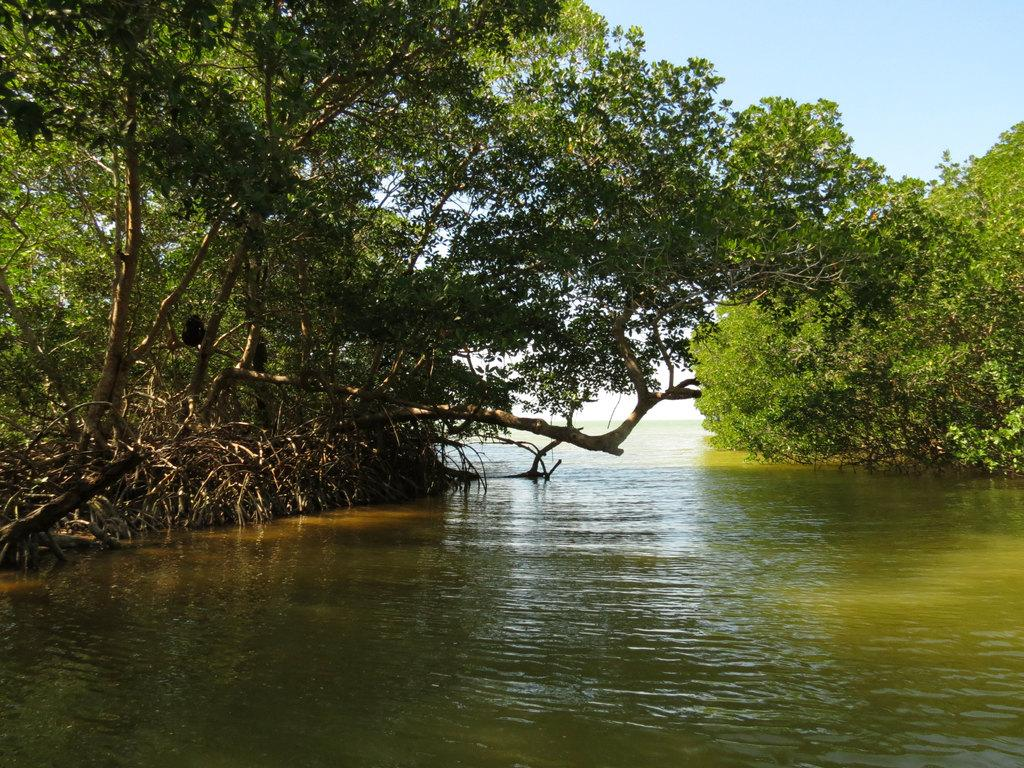What is the primary element visible in the image? There is water in the image. What type of vegetation can be seen in the image? There are plants and trees in the image. What is the natural setting in the image? The natural setting includes water, plants, and trees. What is visible in the background of the image? The sky is visible in the image. Can you see a face twisted in anger in the image? There is no face or any indication of emotion present in the image. 